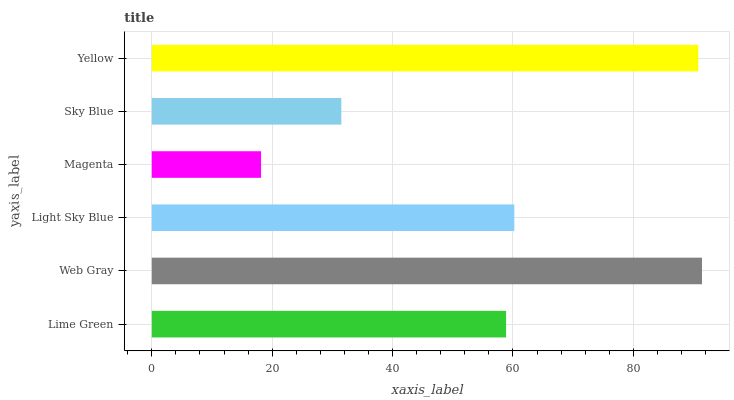Is Magenta the minimum?
Answer yes or no. Yes. Is Web Gray the maximum?
Answer yes or no. Yes. Is Light Sky Blue the minimum?
Answer yes or no. No. Is Light Sky Blue the maximum?
Answer yes or no. No. Is Web Gray greater than Light Sky Blue?
Answer yes or no. Yes. Is Light Sky Blue less than Web Gray?
Answer yes or no. Yes. Is Light Sky Blue greater than Web Gray?
Answer yes or no. No. Is Web Gray less than Light Sky Blue?
Answer yes or no. No. Is Light Sky Blue the high median?
Answer yes or no. Yes. Is Lime Green the low median?
Answer yes or no. Yes. Is Yellow the high median?
Answer yes or no. No. Is Light Sky Blue the low median?
Answer yes or no. No. 